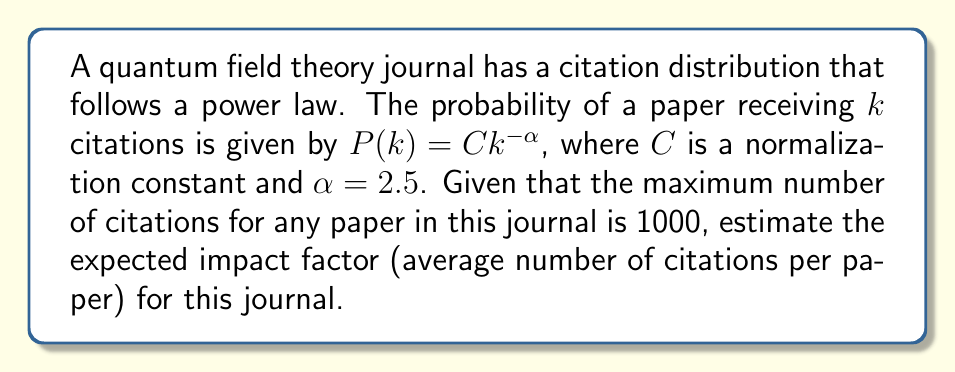Provide a solution to this math problem. To solve this problem, we need to follow these steps:

1. Determine the normalization constant $C$:
   $$\sum_{k=1}^{1000} Ck^{-\alpha} = 1$$
   $$C \sum_{k=1}^{1000} k^{-2.5} = 1$$
   $$C \approx \frac{1}{1.95}$$ (using numerical approximation)

2. Calculate the expected value:
   $$E[k] = \sum_{k=1}^{1000} k \cdot P(k) = \sum_{k=1}^{1000} k \cdot Ck^{-2.5}$$
   $$E[k] = C \sum_{k=1}^{1000} k^{-1.5}$$

3. Evaluate the sum:
   $$\sum_{k=1}^{1000} k^{-1.5} \approx 3.03$$ (using numerical approximation)

4. Calculate the final result:
   $$E[k] = C \cdot 3.03 \approx \frac{1}{1.95} \cdot 3.03 \approx 1.55$$

Therefore, the expected impact factor (average number of citations per paper) for this journal is approximately 1.55.
Answer: 1.55 